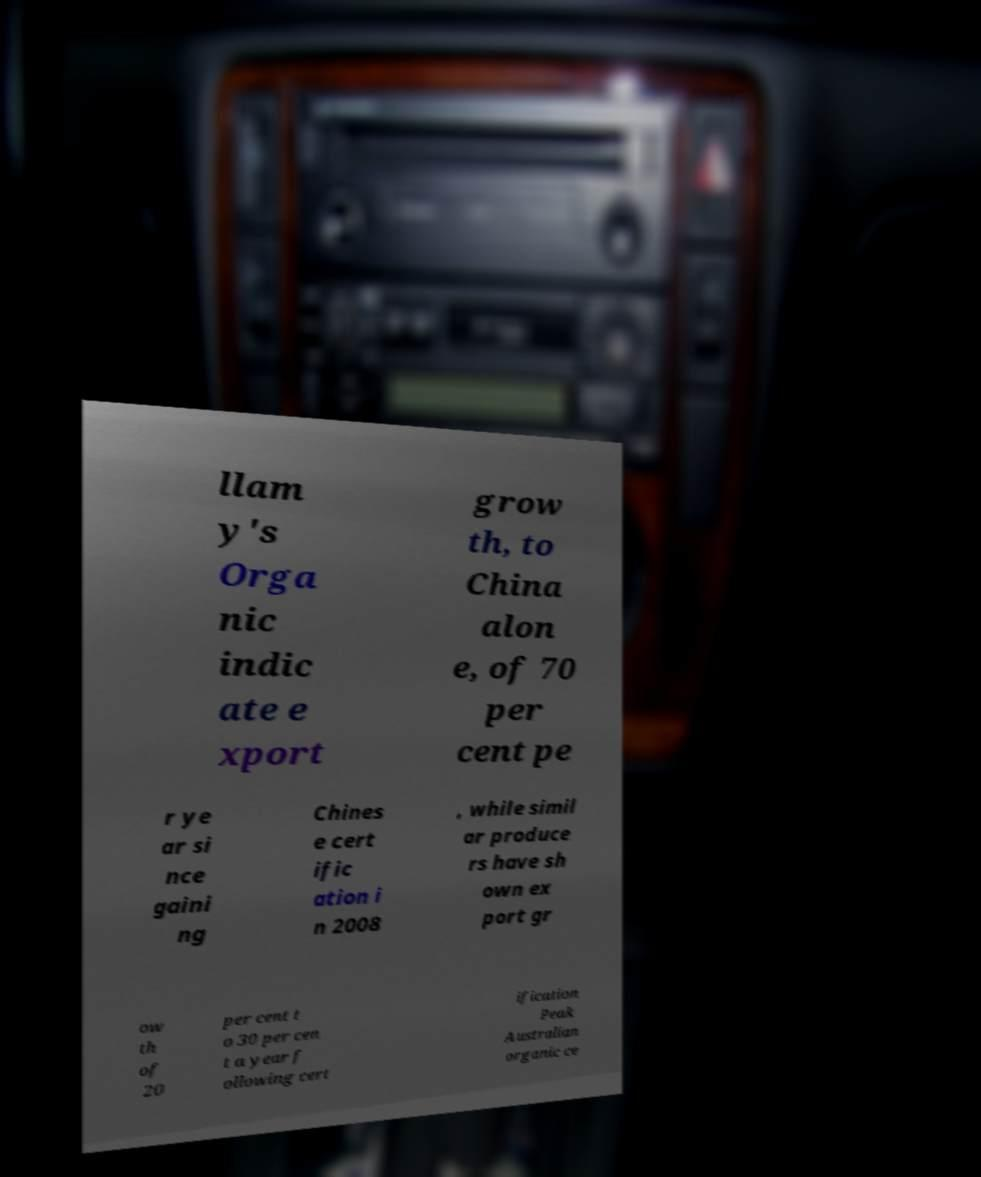I need the written content from this picture converted into text. Can you do that? llam y's Orga nic indic ate e xport grow th, to China alon e, of 70 per cent pe r ye ar si nce gaini ng Chines e cert ific ation i n 2008 , while simil ar produce rs have sh own ex port gr ow th of 20 per cent t o 30 per cen t a year f ollowing cert ification Peak Australian organic ce 